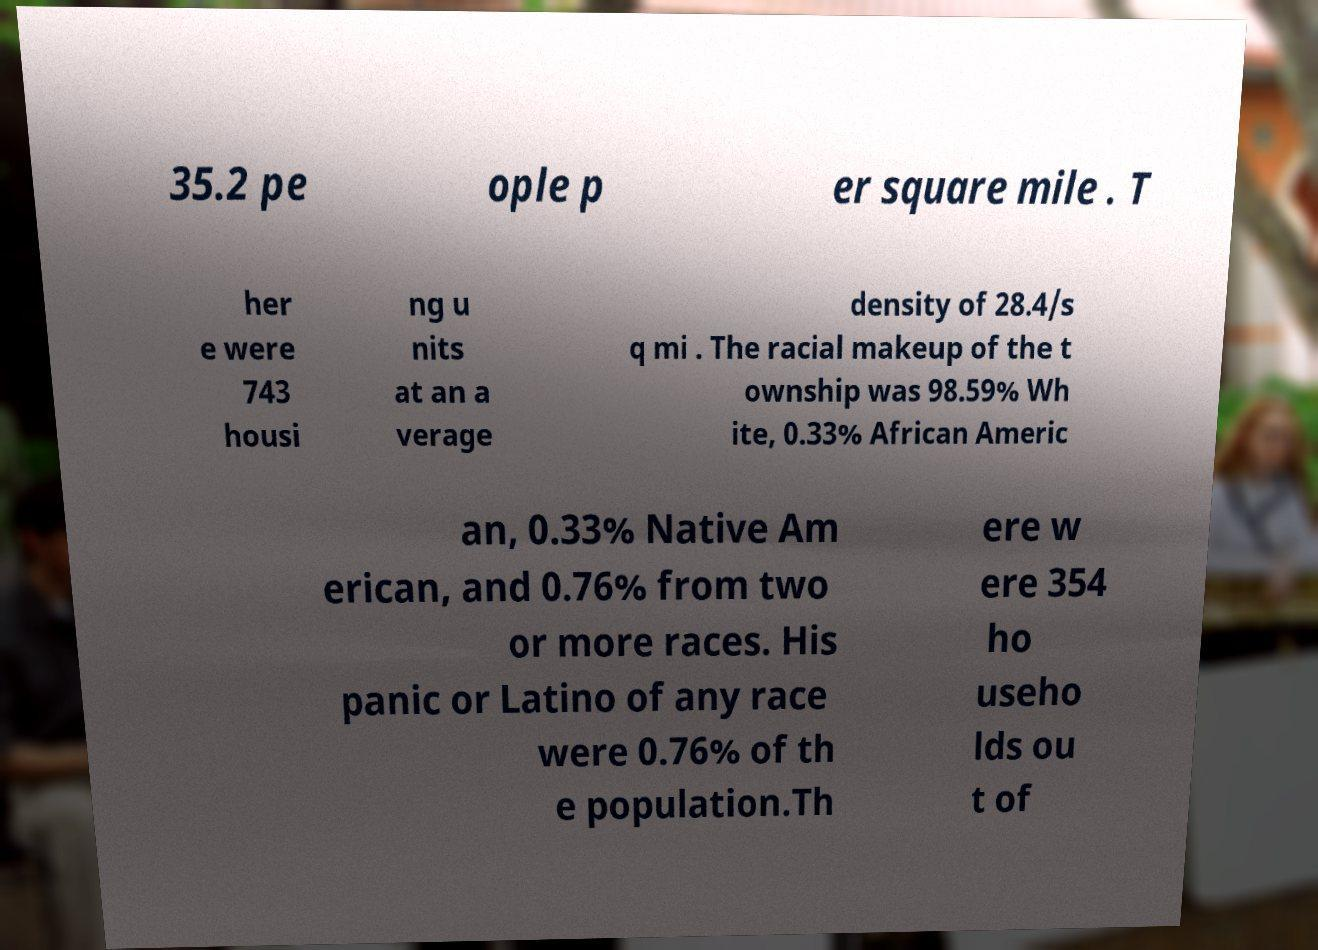I need the written content from this picture converted into text. Can you do that? 35.2 pe ople p er square mile . T her e were 743 housi ng u nits at an a verage density of 28.4/s q mi . The racial makeup of the t ownship was 98.59% Wh ite, 0.33% African Americ an, 0.33% Native Am erican, and 0.76% from two or more races. His panic or Latino of any race were 0.76% of th e population.Th ere w ere 354 ho useho lds ou t of 